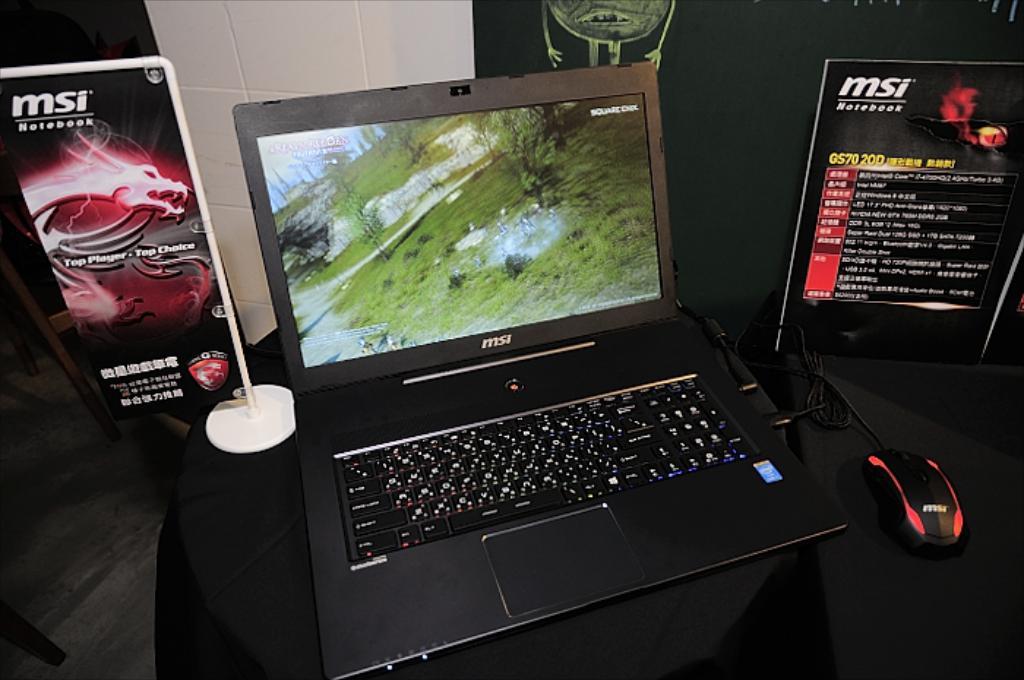What is the name on the dragon poster?
Your answer should be very brief. Msi. 